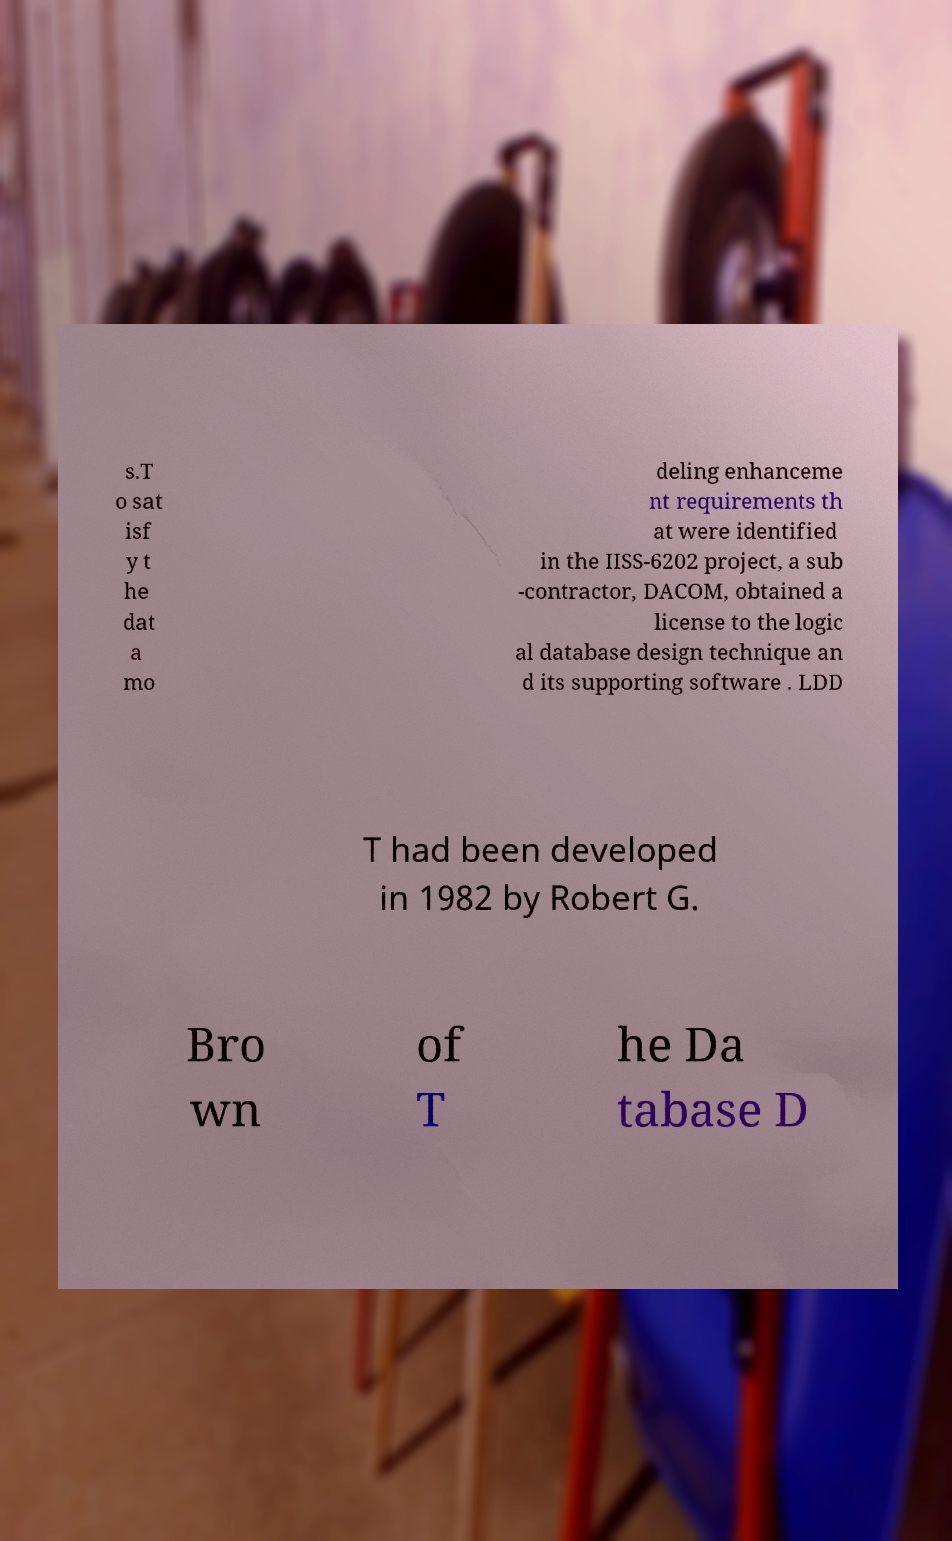Please identify and transcribe the text found in this image. s.T o sat isf y t he dat a mo deling enhanceme nt requirements th at were identified in the IISS-6202 project, a sub -contractor, DACOM, obtained a license to the logic al database design technique an d its supporting software . LDD T had been developed in 1982 by Robert G. Bro wn of T he Da tabase D 